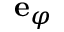<formula> <loc_0><loc_0><loc_500><loc_500>{ e } _ { \varphi }</formula> 